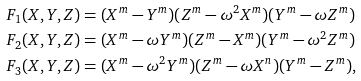<formula> <loc_0><loc_0><loc_500><loc_500>F _ { 1 } ( X , Y , Z ) & = ( X ^ { m } - Y ^ { m } ) ( Z ^ { m } - \omega ^ { 2 } X ^ { m } ) ( Y ^ { m } - \omega Z ^ { m } ) \\ F _ { 2 } ( X , Y , Z ) & = ( X ^ { m } - \omega Y ^ { m } ) ( Z ^ { m } - X ^ { m } ) ( Y ^ { m } - \omega ^ { 2 } Z ^ { m } ) \\ F _ { 3 } ( X , Y , Z ) & = ( X ^ { m } - \omega ^ { 2 } Y ^ { m } ) ( Z ^ { m } - \omega X ^ { n } ) ( Y ^ { m } - Z ^ { m } ) ,</formula> 